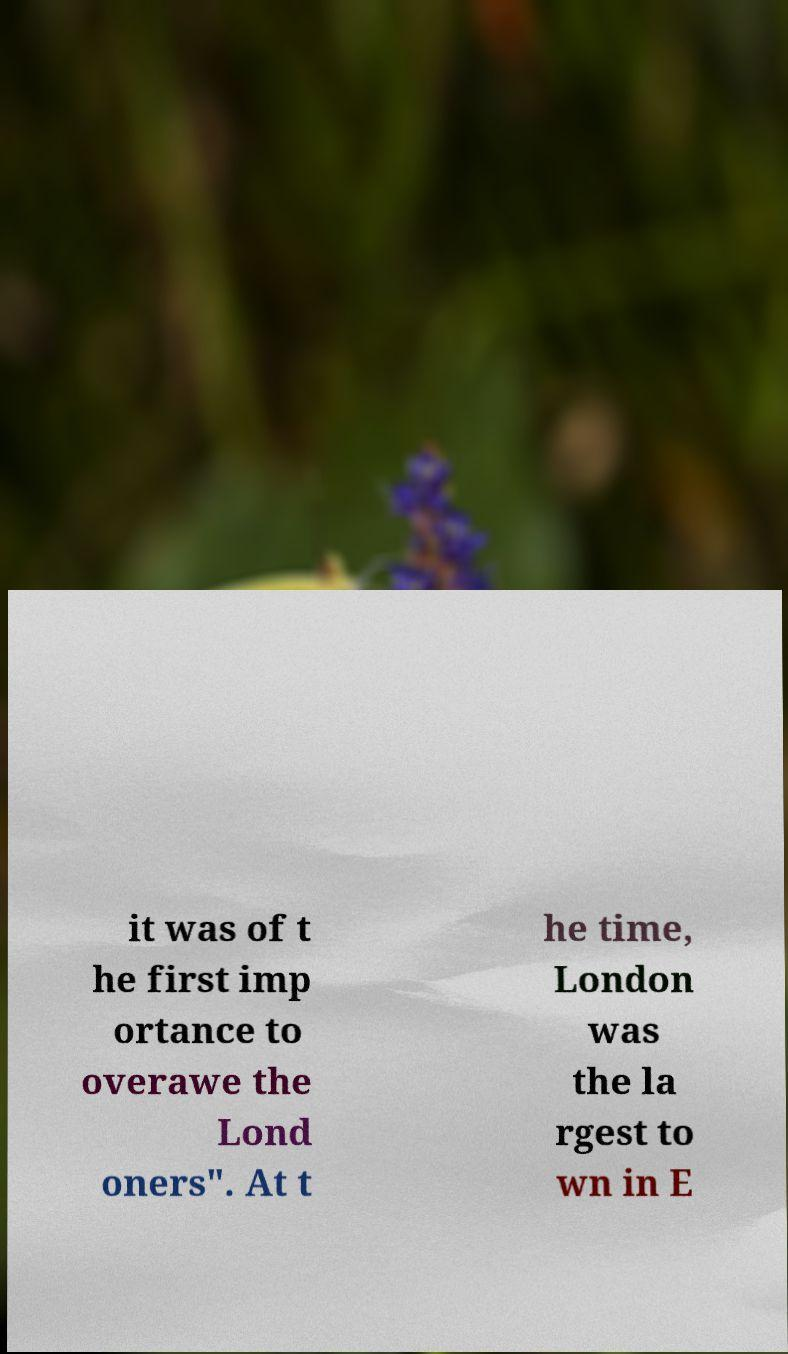For documentation purposes, I need the text within this image transcribed. Could you provide that? it was of t he first imp ortance to overawe the Lond oners". At t he time, London was the la rgest to wn in E 